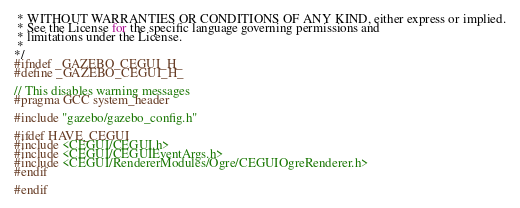<code> <loc_0><loc_0><loc_500><loc_500><_C_> * WITHOUT WARRANTIES OR CONDITIONS OF ANY KIND, either express or implied.
 * See the License for the specific language governing permissions and
 * limitations under the License.
 *
*/
#ifndef _GAZEBO_CEGUI_H_
#define _GAZEBO_CEGUI_H_

// This disables warning messages
#pragma GCC system_header

#include "gazebo/gazebo_config.h"

#ifdef HAVE_CEGUI
#include <CEGUI/CEGUI.h>
#include <CEGUI/CEGUIEventArgs.h>
#include <CEGUI/RendererModules/Ogre/CEGUIOgreRenderer.h>
#endif

#endif
</code> 